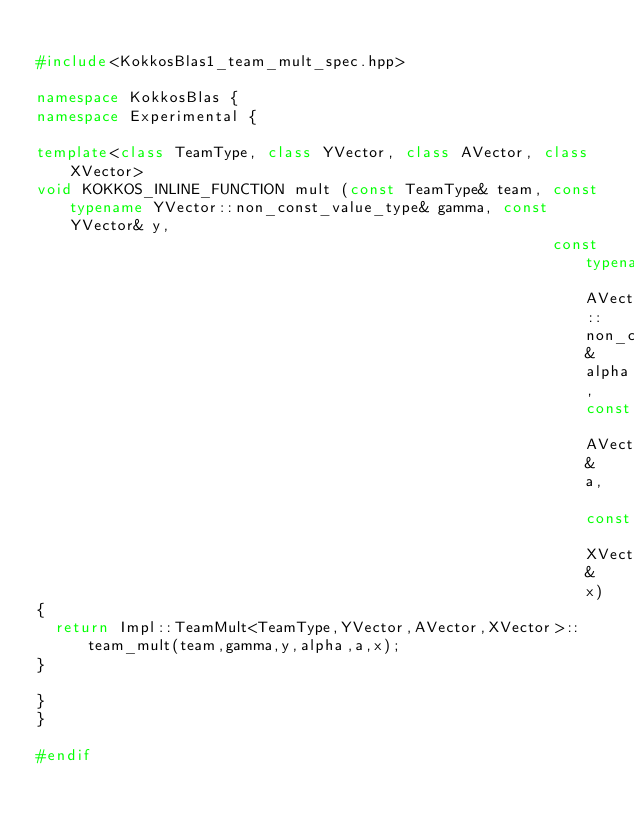Convert code to text. <code><loc_0><loc_0><loc_500><loc_500><_C++_>
#include<KokkosBlas1_team_mult_spec.hpp>

namespace KokkosBlas {
namespace Experimental {

template<class TeamType, class YVector, class AVector, class XVector>
void KOKKOS_INLINE_FUNCTION mult (const TeamType& team, const typename YVector::non_const_value_type& gamma, const YVector& y,
                                                        const typename AVector::non_const_value_type& alpha, const AVector& a, const XVector& x)
{
  return Impl::TeamMult<TeamType,YVector,AVector,XVector>::team_mult(team,gamma,y,alpha,a,x);
}

}
}

#endif
</code> 